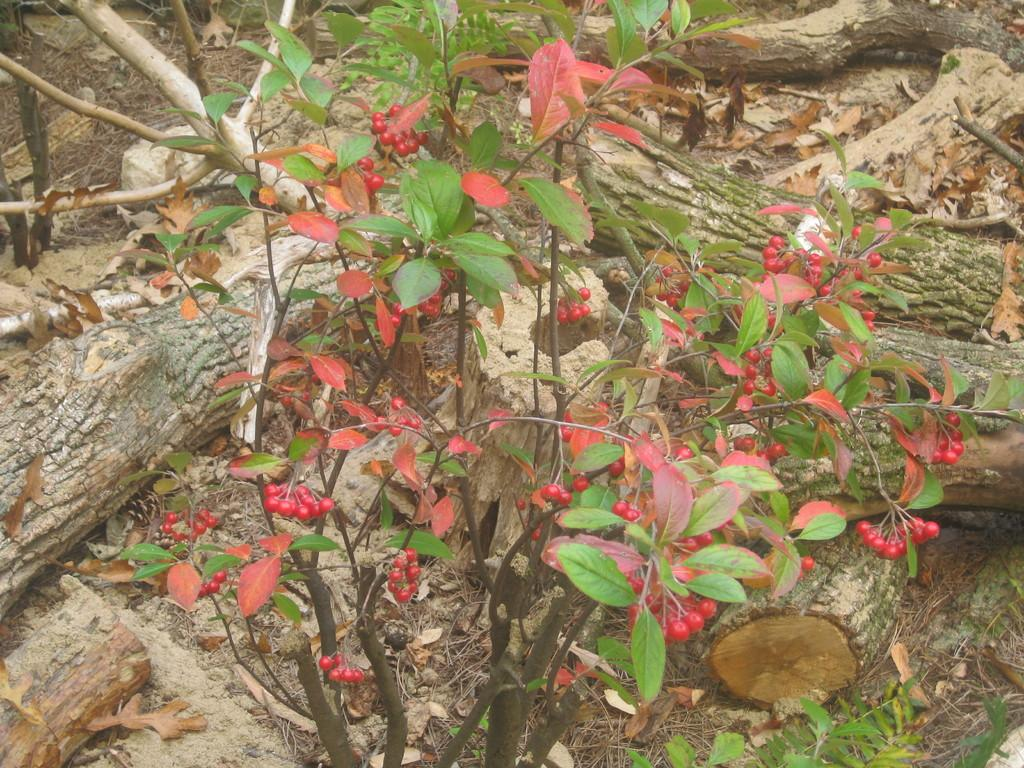What type of living organism can be seen in the image? There is a plant in the image. What part of the plant is visible in the image? There are branches visible in the image. What type of glue is being used to attach the box to the plant in the image? There is no glue, box, or any attachment process depicted in the image; it simply features a plant with visible branches. 